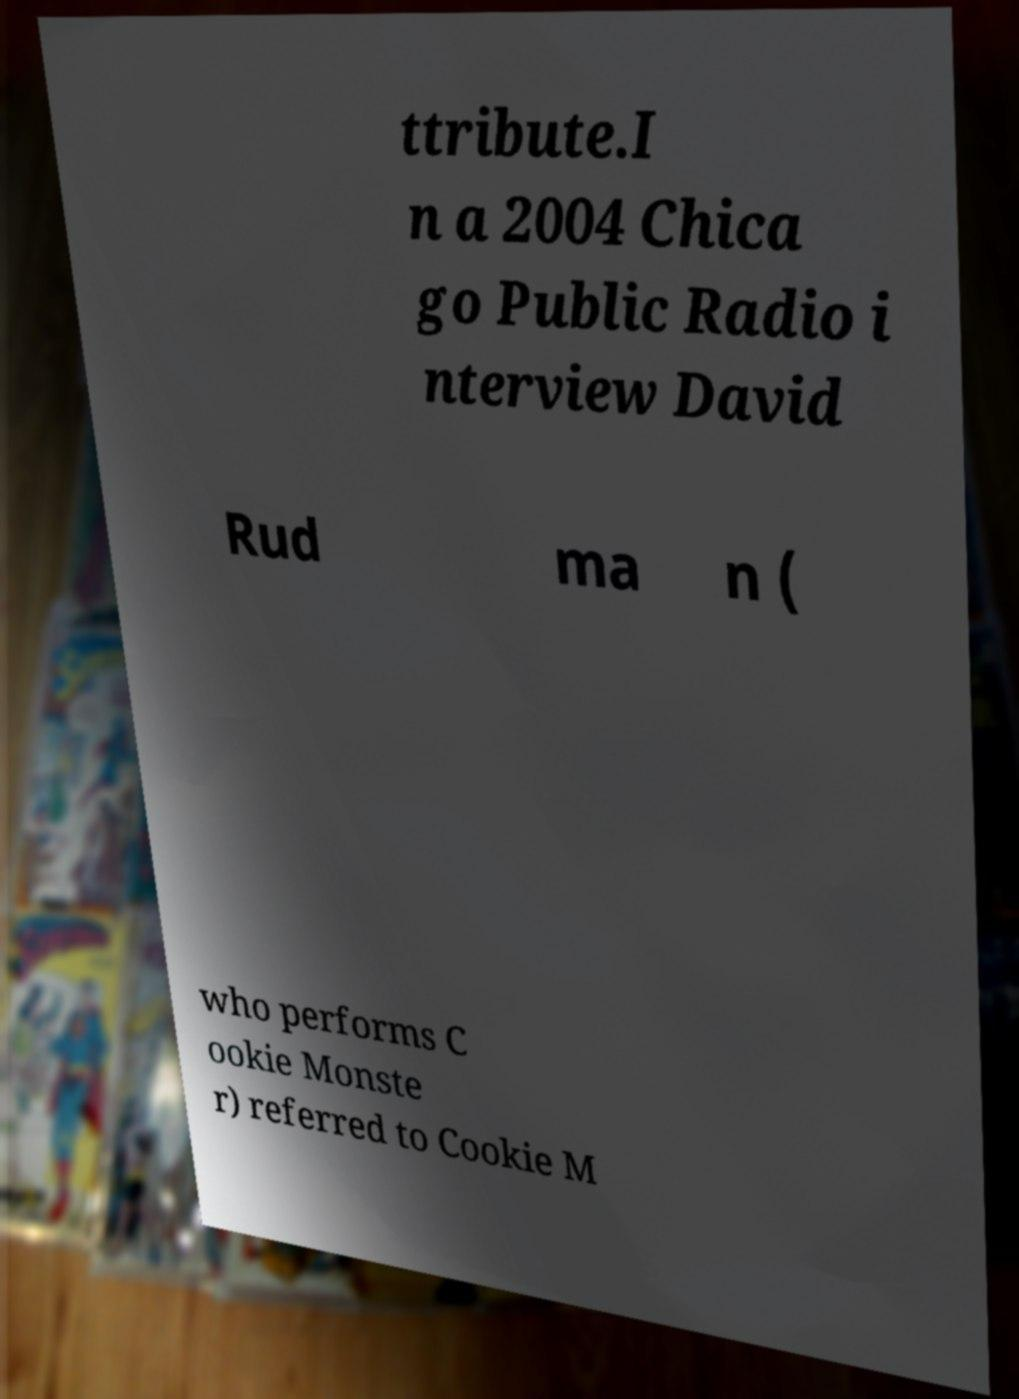There's text embedded in this image that I need extracted. Can you transcribe it verbatim? ttribute.I n a 2004 Chica go Public Radio i nterview David Rud ma n ( who performs C ookie Monste r) referred to Cookie M 